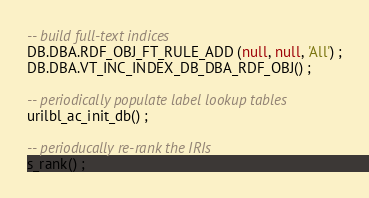Convert code to text. <code><loc_0><loc_0><loc_500><loc_500><_SQL_>
-- build full-text indices
DB.DBA.RDF_OBJ_FT_RULE_ADD (null, null, 'All') ;
DB.DBA.VT_INC_INDEX_DB_DBA_RDF_OBJ() ;

-- periodically populate label lookup tables
urilbl_ac_init_db() ;

-- perioducally re-rank the IRIs
s_rank() ;
</code> 